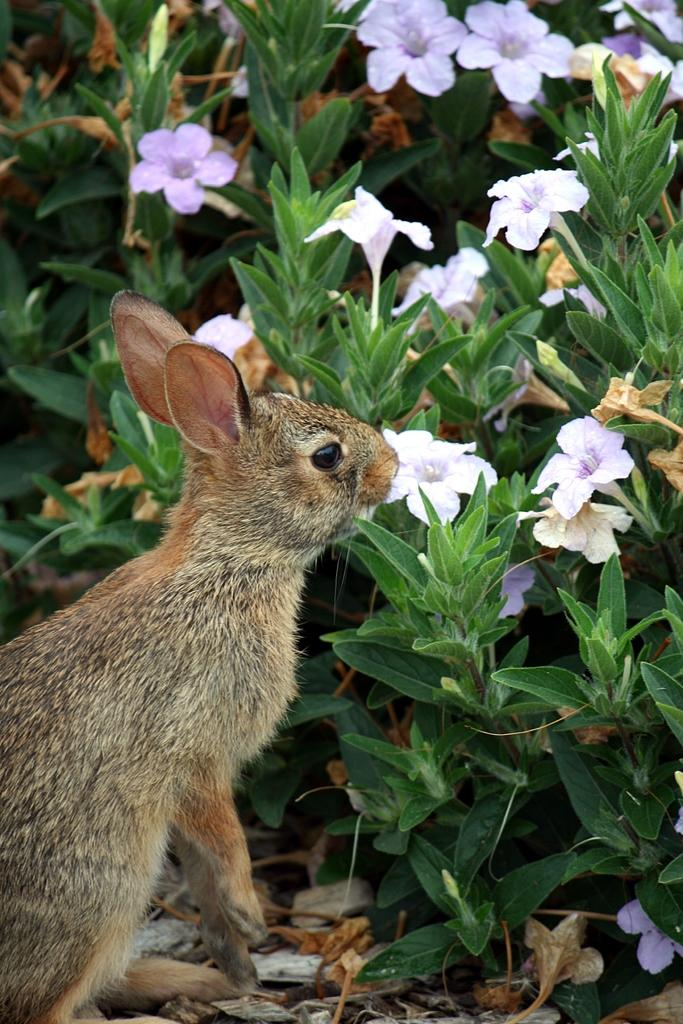What animal is located on the left side of the image? There is a rabbit on the left side of the image. What type of vegetation is on the right side of the image? There are flower plants on the right side of the image. Where is the yoke located in the image? There is no yoke present in the image. What type of kettle can be seen in the image? There is no kettle present in the image. 